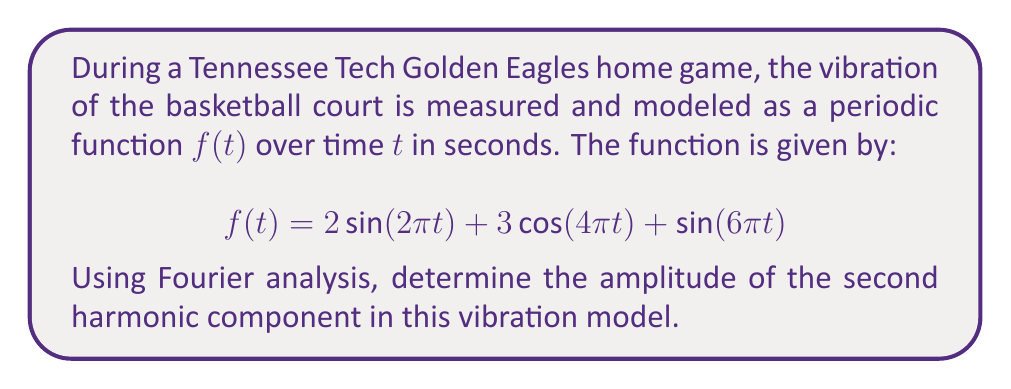Provide a solution to this math problem. Let's approach this step-by-step:

1) In Fourier analysis, a periodic function can be represented as a sum of sine and cosine terms with different frequencies (harmonics).

2) The general form of a Fourier series is:

   $$f(t) = a_0 + \sum_{n=1}^{\infty} (a_n \cos(2\pi n f_0 t) + b_n \sin(2\pi n f_0 t))$$

   where $f_0$ is the fundamental frequency.

3) In our given function:
   $$f(t) = 2\sin(2\pi t) + 3\cos(4\pi t) + \sin(6\pi t)$$

4) We can identify the terms:
   - $2\sin(2\pi t)$ is the first harmonic (n=1)
   - $3\cos(4\pi t)$ is the second harmonic (n=2)
   - $\sin(6\pi t)$ is the third harmonic (n=3)

5) The amplitude of a harmonic is given by $\sqrt{a_n^2 + b_n^2}$, where $a_n$ is the coefficient of the cosine term and $b_n$ is the coefficient of the sine term for that harmonic.

6) For the second harmonic (n=2):
   $a_2 = 3$ (coefficient of $\cos(4\pi t)$)
   $b_2 = 0$ (no $\sin(4\pi t)$ term)

7) Therefore, the amplitude of the second harmonic is:
   $$\sqrt{a_2^2 + b_2^2} = \sqrt{3^2 + 0^2} = \sqrt{9} = 3$$
Answer: 3 